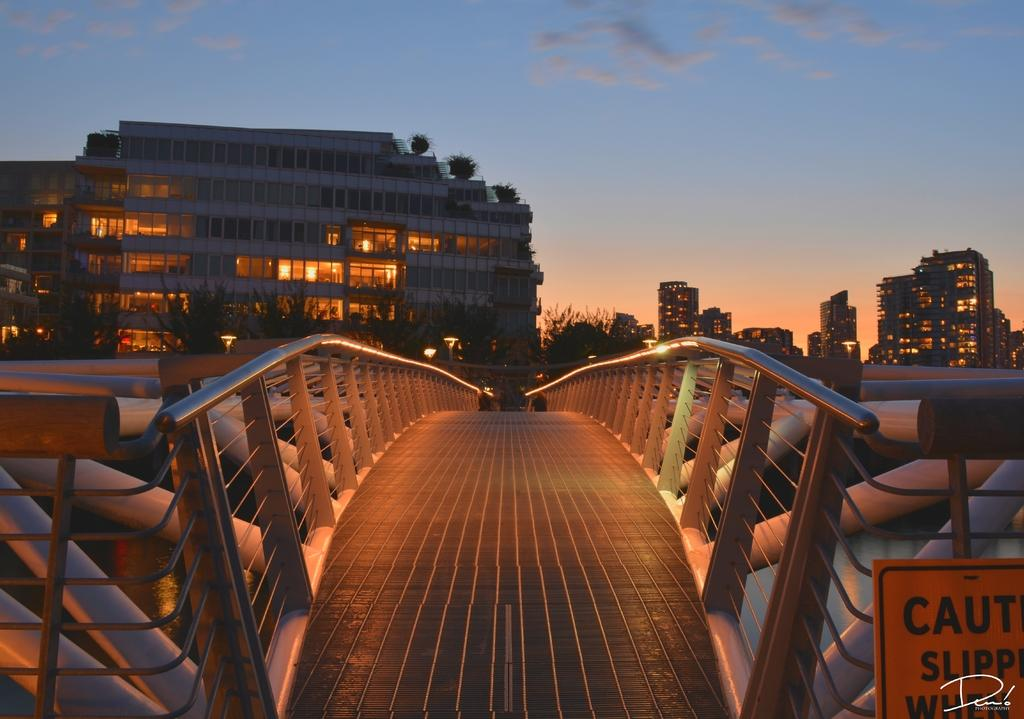<image>
Write a terse but informative summary of the picture. A sign at the entrance to an urban bridge tells the public to use caution. 